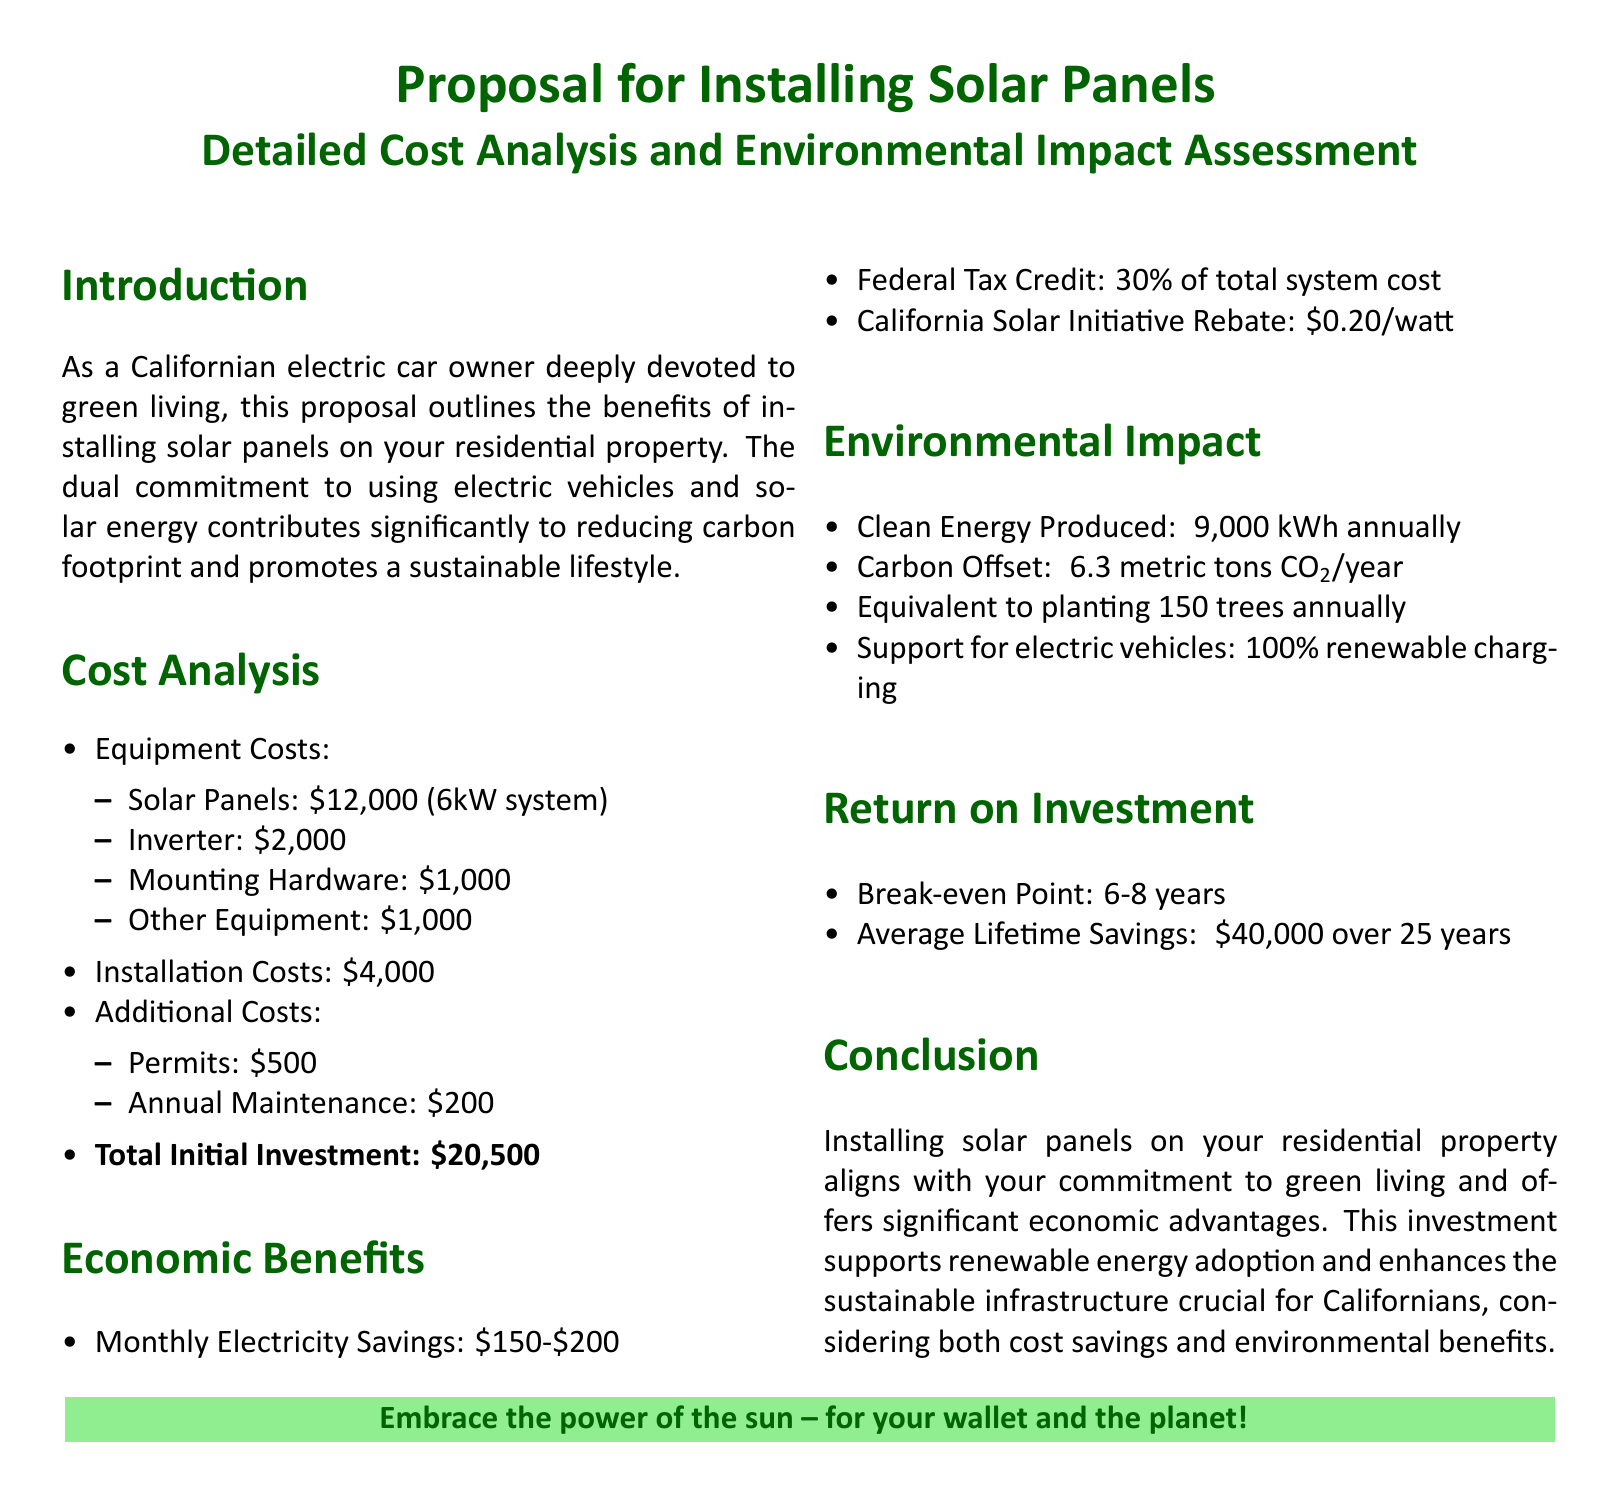what is the initial cost of solar panels? The document lists the cost of solar panels as part of the equipment costs, which is $12,000 for a 6kW system.
Answer: $12,000 what is the total initial investment? The total initial investment is calculated from the costs outlined in the document, which sum up to $20,500.
Answer: $20,500 how much money can be saved monthly on electricity? The document states that monthly electricity savings can range between $150 and $200.
Answer: $150-$200 what is the federal tax credit percentage? The federal tax credit mentioned in the document is 30% of the total system cost.
Answer: 30% how long is the break-even point? According to the document, the break-even point for the investment in solar panels is between 6 to 8 years.
Answer: 6-8 years how much carbon is offset annually by the solar panels? The document indicates that the solar panels will offset approximately 6.3 metric tons of CO2 each year.
Answer: 6.3 metric tons CO2/year what is the annual clean energy production? The document states that the clean energy produced by the installation would be around 9,000 kWh annually.
Answer: ~9,000 kWh annually how many trees are equivalent to the carbon offset? The document claims that the carbon offset is equivalent to planting about 150 trees every year.
Answer: 150 trees what is the average lifetime savings provided by the solar panels? The average lifetime savings over 25 years, as mentioned in the document, is about $40,000.
Answer: ~$40,000 